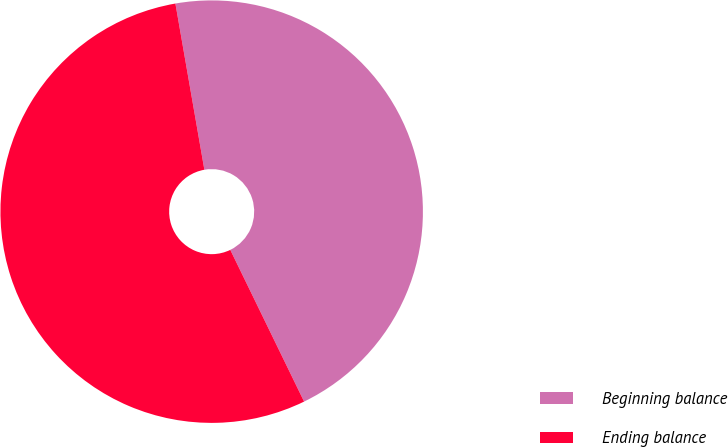<chart> <loc_0><loc_0><loc_500><loc_500><pie_chart><fcel>Beginning balance<fcel>Ending balance<nl><fcel>45.54%<fcel>54.46%<nl></chart> 